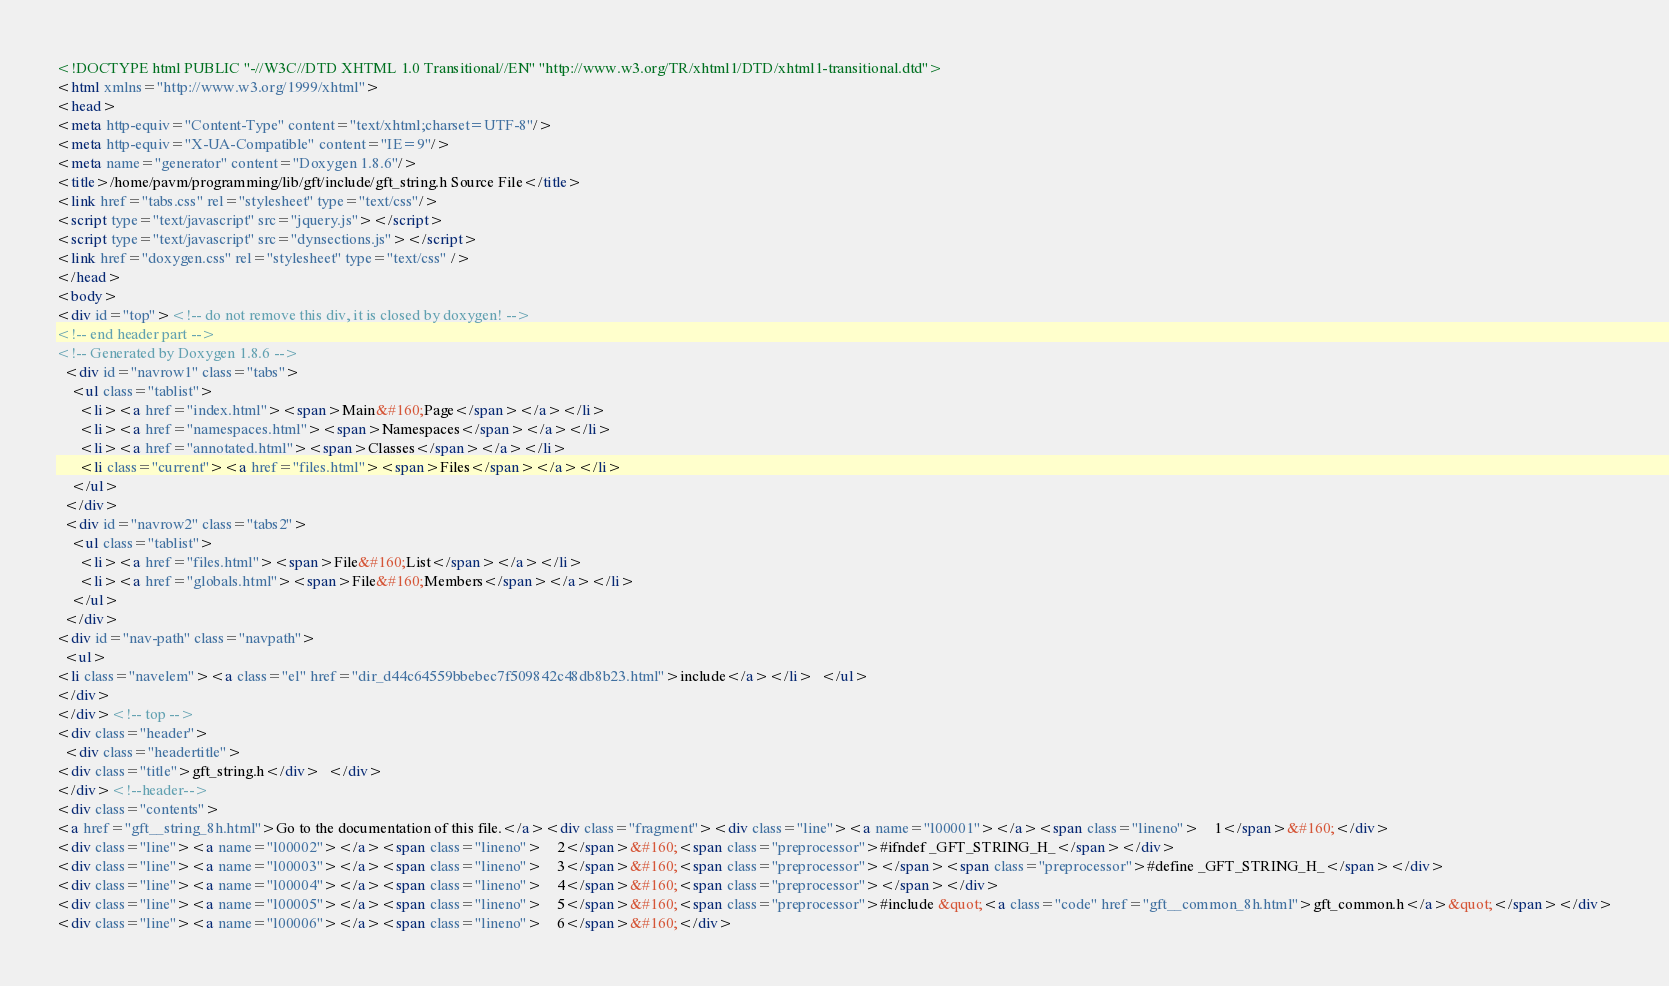Convert code to text. <code><loc_0><loc_0><loc_500><loc_500><_HTML_><!DOCTYPE html PUBLIC "-//W3C//DTD XHTML 1.0 Transitional//EN" "http://www.w3.org/TR/xhtml1/DTD/xhtml1-transitional.dtd">
<html xmlns="http://www.w3.org/1999/xhtml">
<head>
<meta http-equiv="Content-Type" content="text/xhtml;charset=UTF-8"/>
<meta http-equiv="X-UA-Compatible" content="IE=9"/>
<meta name="generator" content="Doxygen 1.8.6"/>
<title>/home/pavm/programming/lib/gft/include/gft_string.h Source File</title>
<link href="tabs.css" rel="stylesheet" type="text/css"/>
<script type="text/javascript" src="jquery.js"></script>
<script type="text/javascript" src="dynsections.js"></script>
<link href="doxygen.css" rel="stylesheet" type="text/css" />
</head>
<body>
<div id="top"><!-- do not remove this div, it is closed by doxygen! -->
<!-- end header part -->
<!-- Generated by Doxygen 1.8.6 -->
  <div id="navrow1" class="tabs">
    <ul class="tablist">
      <li><a href="index.html"><span>Main&#160;Page</span></a></li>
      <li><a href="namespaces.html"><span>Namespaces</span></a></li>
      <li><a href="annotated.html"><span>Classes</span></a></li>
      <li class="current"><a href="files.html"><span>Files</span></a></li>
    </ul>
  </div>
  <div id="navrow2" class="tabs2">
    <ul class="tablist">
      <li><a href="files.html"><span>File&#160;List</span></a></li>
      <li><a href="globals.html"><span>File&#160;Members</span></a></li>
    </ul>
  </div>
<div id="nav-path" class="navpath">
  <ul>
<li class="navelem"><a class="el" href="dir_d44c64559bbebec7f509842c48db8b23.html">include</a></li>  </ul>
</div>
</div><!-- top -->
<div class="header">
  <div class="headertitle">
<div class="title">gft_string.h</div>  </div>
</div><!--header-->
<div class="contents">
<a href="gft__string_8h.html">Go to the documentation of this file.</a><div class="fragment"><div class="line"><a name="l00001"></a><span class="lineno">    1</span>&#160;</div>
<div class="line"><a name="l00002"></a><span class="lineno">    2</span>&#160;<span class="preprocessor">#ifndef _GFT_STRING_H_</span></div>
<div class="line"><a name="l00003"></a><span class="lineno">    3</span>&#160;<span class="preprocessor"></span><span class="preprocessor">#define _GFT_STRING_H_</span></div>
<div class="line"><a name="l00004"></a><span class="lineno">    4</span>&#160;<span class="preprocessor"></span></div>
<div class="line"><a name="l00005"></a><span class="lineno">    5</span>&#160;<span class="preprocessor">#include &quot;<a class="code" href="gft__common_8h.html">gft_common.h</a>&quot;</span></div>
<div class="line"><a name="l00006"></a><span class="lineno">    6</span>&#160;</div></code> 